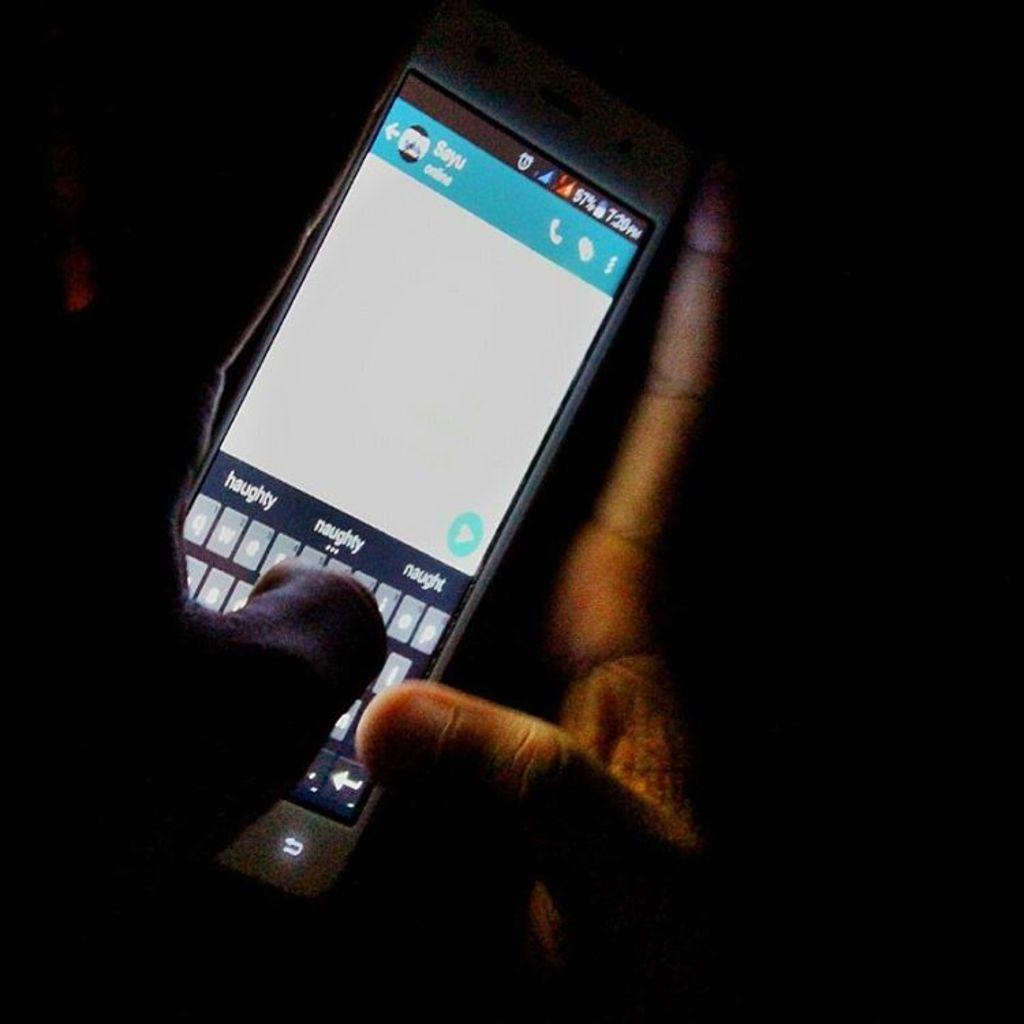<image>
Present a compact description of the photo's key features. A hand holding a phone in the dark; the word haughty is visible on the middle left. 